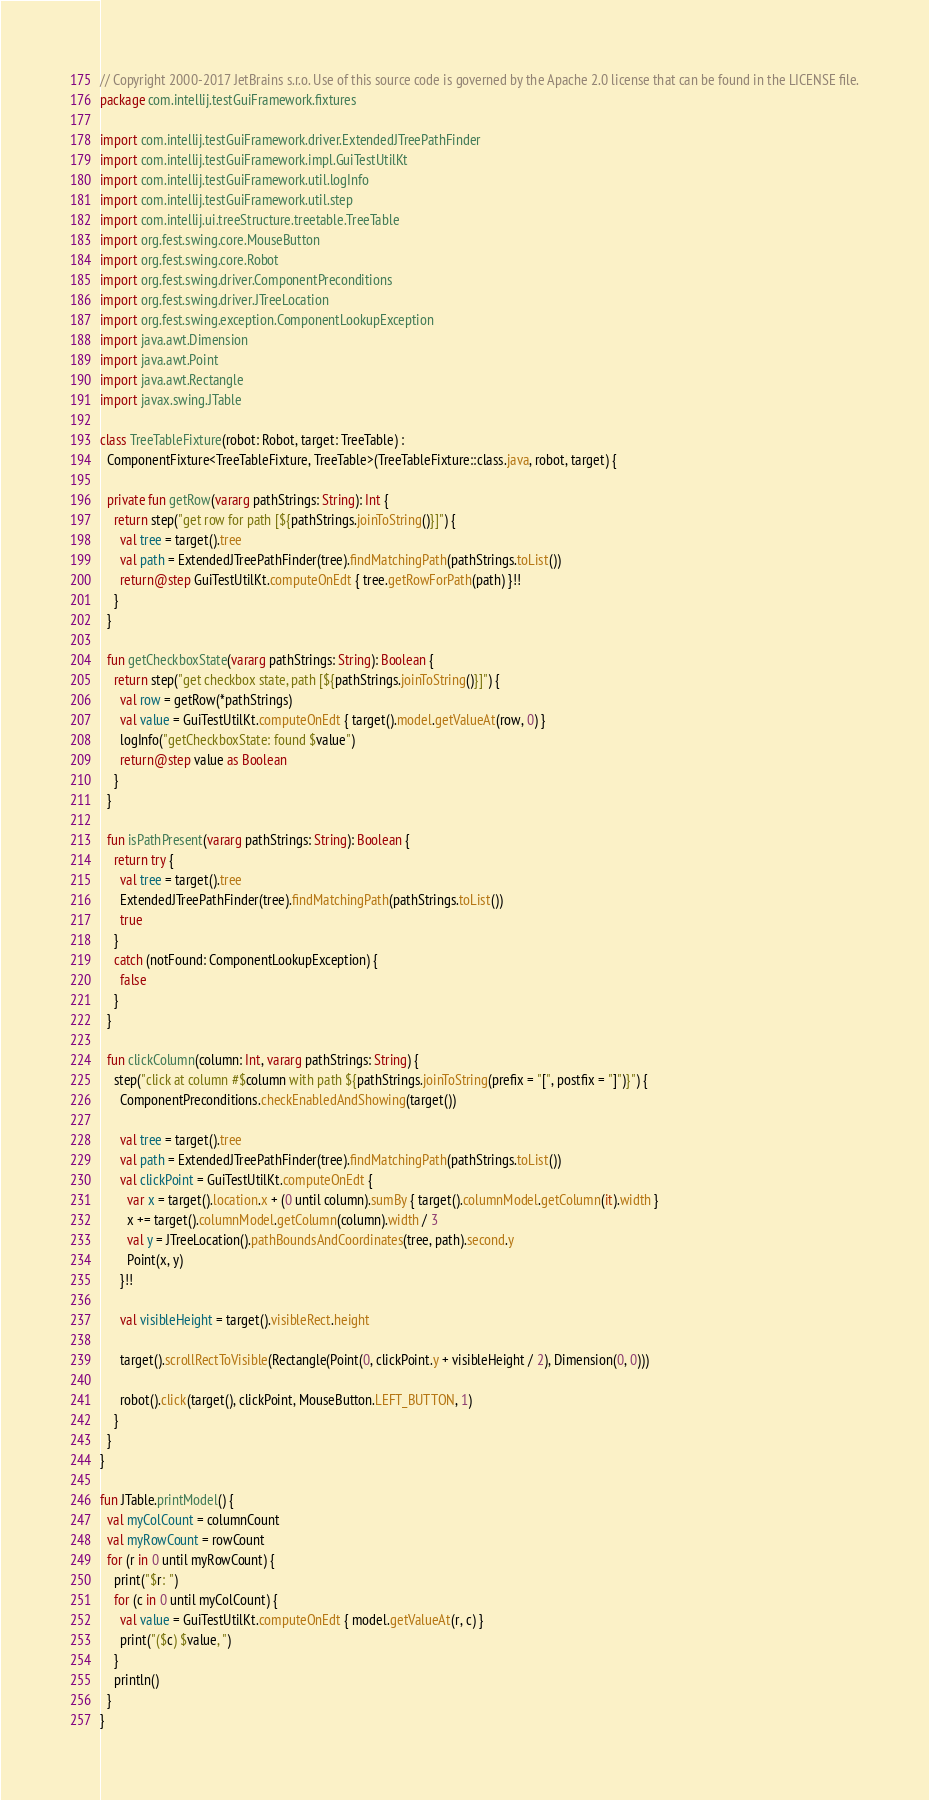Convert code to text. <code><loc_0><loc_0><loc_500><loc_500><_Kotlin_>// Copyright 2000-2017 JetBrains s.r.o. Use of this source code is governed by the Apache 2.0 license that can be found in the LICENSE file.
package com.intellij.testGuiFramework.fixtures

import com.intellij.testGuiFramework.driver.ExtendedJTreePathFinder
import com.intellij.testGuiFramework.impl.GuiTestUtilKt
import com.intellij.testGuiFramework.util.logInfo
import com.intellij.testGuiFramework.util.step
import com.intellij.ui.treeStructure.treetable.TreeTable
import org.fest.swing.core.MouseButton
import org.fest.swing.core.Robot
import org.fest.swing.driver.ComponentPreconditions
import org.fest.swing.driver.JTreeLocation
import org.fest.swing.exception.ComponentLookupException
import java.awt.Dimension
import java.awt.Point
import java.awt.Rectangle
import javax.swing.JTable

class TreeTableFixture(robot: Robot, target: TreeTable) :
  ComponentFixture<TreeTableFixture, TreeTable>(TreeTableFixture::class.java, robot, target) {

  private fun getRow(vararg pathStrings: String): Int {
    return step("get row for path [${pathStrings.joinToString()}]") {
      val tree = target().tree
      val path = ExtendedJTreePathFinder(tree).findMatchingPath(pathStrings.toList())
      return@step GuiTestUtilKt.computeOnEdt { tree.getRowForPath(path) }!!
    }
  }

  fun getCheckboxState(vararg pathStrings: String): Boolean {
    return step("get checkbox state, path [${pathStrings.joinToString()}]") {
      val row = getRow(*pathStrings)
      val value = GuiTestUtilKt.computeOnEdt { target().model.getValueAt(row, 0) }
      logInfo("getCheckboxState: found $value")
      return@step value as Boolean
    }
  }

  fun isPathPresent(vararg pathStrings: String): Boolean {
    return try {
      val tree = target().tree
      ExtendedJTreePathFinder(tree).findMatchingPath(pathStrings.toList())
      true
    }
    catch (notFound: ComponentLookupException) {
      false
    }
  }

  fun clickColumn(column: Int, vararg pathStrings: String) {
    step("click at column #$column with path ${pathStrings.joinToString(prefix = "[", postfix = "]")}") {
      ComponentPreconditions.checkEnabledAndShowing(target())

      val tree = target().tree
      val path = ExtendedJTreePathFinder(tree).findMatchingPath(pathStrings.toList())
      val clickPoint = GuiTestUtilKt.computeOnEdt {
        var x = target().location.x + (0 until column).sumBy { target().columnModel.getColumn(it).width }
        x += target().columnModel.getColumn(column).width / 3
        val y = JTreeLocation().pathBoundsAndCoordinates(tree, path).second.y
        Point(x, y)
      }!!

      val visibleHeight = target().visibleRect.height

      target().scrollRectToVisible(Rectangle(Point(0, clickPoint.y + visibleHeight / 2), Dimension(0, 0)))

      robot().click(target(), clickPoint, MouseButton.LEFT_BUTTON, 1)
    }
  }
}

fun JTable.printModel() {
  val myColCount = columnCount
  val myRowCount = rowCount
  for (r in 0 until myRowCount) {
    print("$r: ")
    for (c in 0 until myColCount) {
      val value = GuiTestUtilKt.computeOnEdt { model.getValueAt(r, c) }
      print("($c) $value, ")
    }
    println()
  }
}</code> 